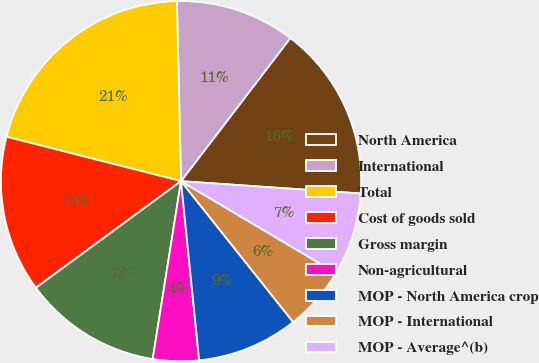Convert chart to OTSL. <chart><loc_0><loc_0><loc_500><loc_500><pie_chart><fcel>North America<fcel>International<fcel>Total<fcel>Cost of goods sold<fcel>Gross margin<fcel>Non-agricultural<fcel>MOP - North America crop<fcel>MOP - International<fcel>MOP - Average^(b)<nl><fcel>15.71%<fcel>10.74%<fcel>20.67%<fcel>14.05%<fcel>12.4%<fcel>4.12%<fcel>9.09%<fcel>5.78%<fcel>7.43%<nl></chart> 